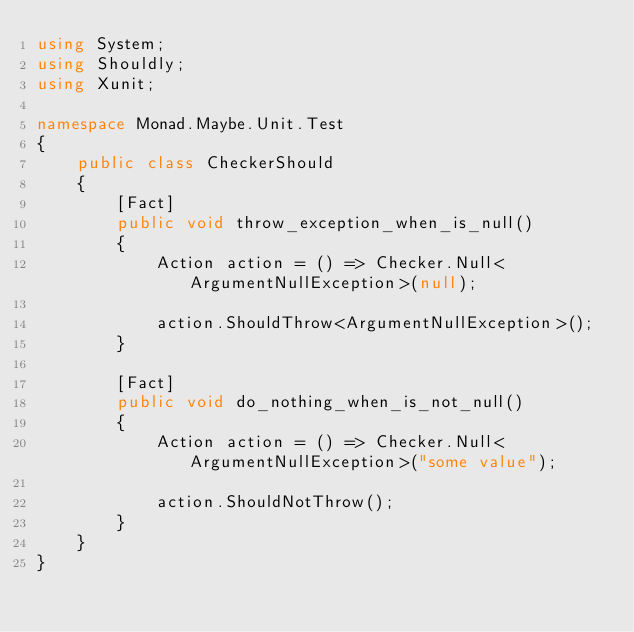Convert code to text. <code><loc_0><loc_0><loc_500><loc_500><_C#_>using System;
using Shouldly;
using Xunit;

namespace Monad.Maybe.Unit.Test
{
    public class CheckerShould
    {
        [Fact]
        public void throw_exception_when_is_null()
        {
            Action action = () => Checker.Null<ArgumentNullException>(null);

            action.ShouldThrow<ArgumentNullException>();
        }
        
        [Fact]
        public void do_nothing_when_is_not_null()
        {
            Action action = () => Checker.Null<ArgumentNullException>("some value");

            action.ShouldNotThrow();
        }
    }
}</code> 